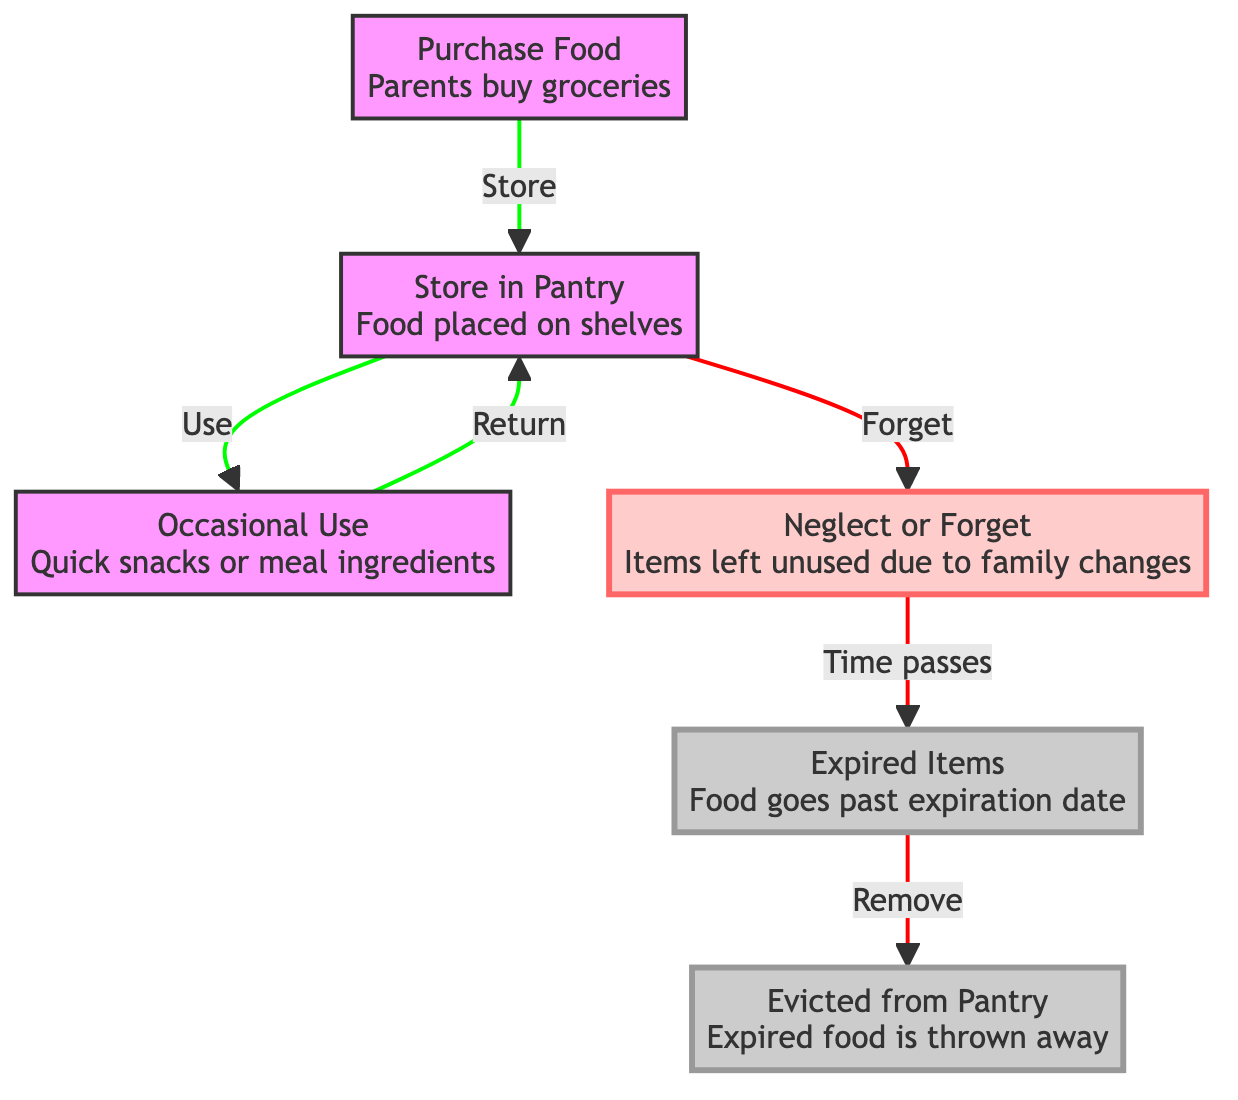What is the first node in the diagram? The first node is labeled "Purchase Food". It represents the starting point of the food cycle when parents buy groceries.
Answer: Purchase Food What happens to food after it is stored in the pantry? After food is stored in the pantry, it can be used for "Occasional Use", which includes quick snacks or meal ingredients.
Answer: Occasional Use How many main nodes are there in the diagram? The diagram has six main nodes: Purchase Food, Store in Pantry, Occasional Use, Neglect or Forget, Expired Items, and Evicted from Pantry.
Answer: Six What color represents the nodes related to neglect? The nodes related to neglect are represented in a light red color, indicating they are in a neglect state.
Answer: Light red Which node comes after "Neglect or Forget"? The node that comes after "Neglect or Forget" is "Expired Items". This indicates that neglect leads to food expiration.
Answer: Expired Items What happens to expired items? Expired items are "Evicted from Pantry" when they are thrown away. This shows the final step of food that is no longer usable.
Answer: Evicted from Pantry Did the food follow the same path regardless of usage? No, the food can either be used occasionally, which brings it back to the pantry, or it can be forgotten, leading to expiration. This demonstrates that usage and neglect are two different paths.
Answer: No What is the progression of food after it is purchased? After being purchased, food is stored in the pantry, occasionally used, and can either be forgotten or lead to expiration if not used. This outlines the cycle food goes through.
Answer: Stored in Pantry, Occasionally Use, Forget What do the colors in the diagram indicate? The colors represent different states of food: default for normal use, light red for neglect, and light gray for expired items, indicating their respective statuses in the food cycle.
Answer: Different states of food 